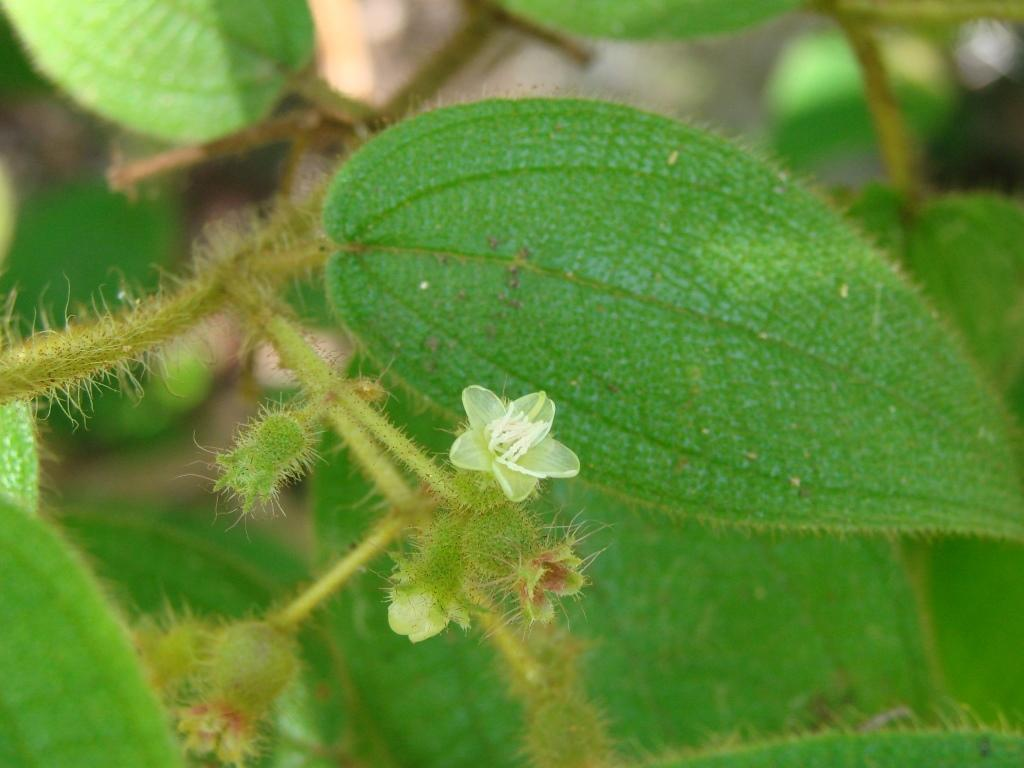What type of plant parts can be seen in the image? There are leaves and flowers in the image. Where are the leaves and flowers located on the plant? The leaves and flowers are on the stem of a plant. What type of engine is powering the skate in the image? There is no skate or engine present in the image; it features leaves and flowers on a plant stem. 